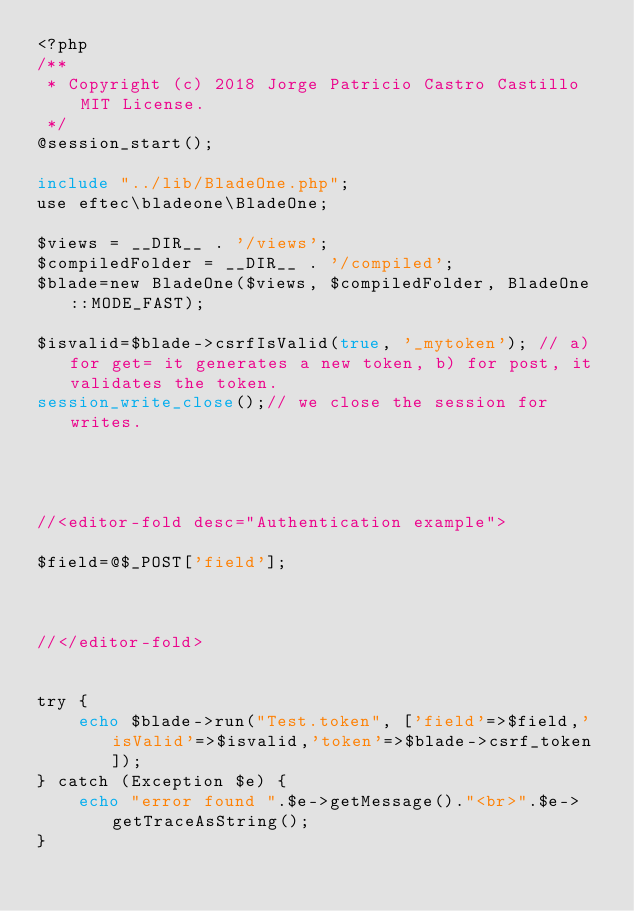Convert code to text. <code><loc_0><loc_0><loc_500><loc_500><_PHP_><?php
/**
 * Copyright (c) 2018 Jorge Patricio Castro Castillo MIT License.
 */
@session_start();

include "../lib/BladeOne.php";
use eftec\bladeone\BladeOne;

$views = __DIR__ . '/views';
$compiledFolder = __DIR__ . '/compiled';
$blade=new BladeOne($views, $compiledFolder, BladeOne::MODE_FAST);

$isvalid=$blade->csrfIsValid(true, '_mytoken'); // a) for get= it generates a new token, b) for post, it validates the token.
session_write_close();// we close the session for writes.




//<editor-fold desc="Authentication example">

$field=@$_POST['field'];



//</editor-fold>


try {
    echo $blade->run("Test.token", ['field'=>$field,'isValid'=>$isvalid,'token'=>$blade->csrf_token]);
} catch (Exception $e) {
    echo "error found ".$e->getMessage()."<br>".$e->getTraceAsString();
}
</code> 